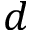Convert formula to latex. <formula><loc_0><loc_0><loc_500><loc_500>d</formula> 